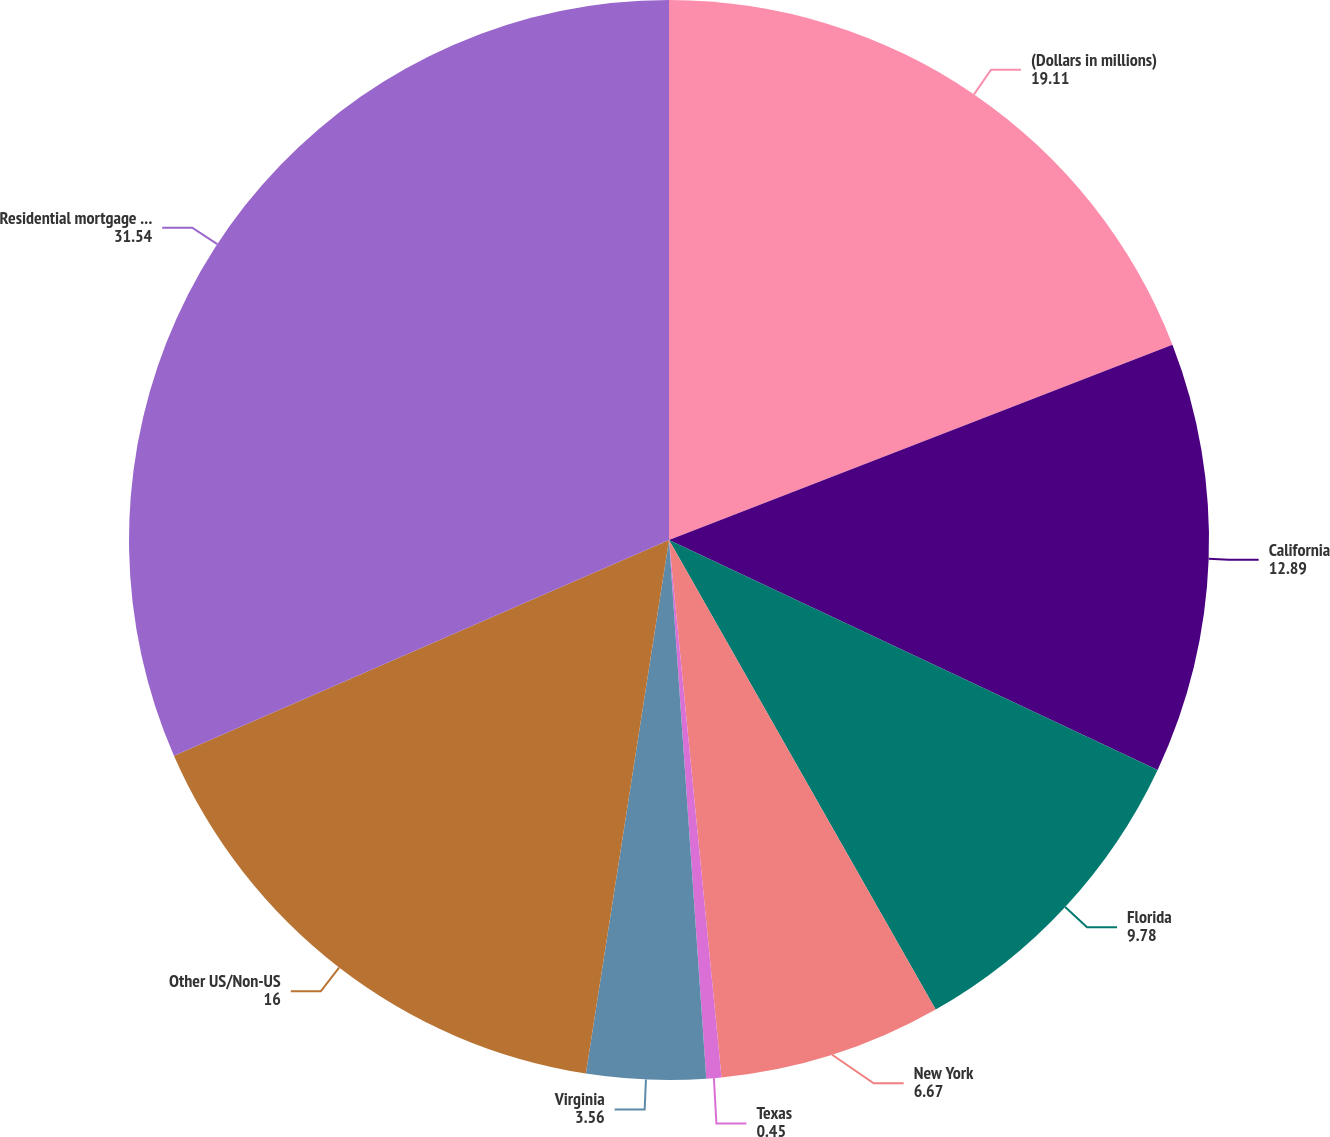Convert chart to OTSL. <chart><loc_0><loc_0><loc_500><loc_500><pie_chart><fcel>(Dollars in millions)<fcel>California<fcel>Florida<fcel>New York<fcel>Texas<fcel>Virginia<fcel>Other US/Non-US<fcel>Residential mortgage loans (2)<nl><fcel>19.11%<fcel>12.89%<fcel>9.78%<fcel>6.67%<fcel>0.45%<fcel>3.56%<fcel>16.0%<fcel>31.54%<nl></chart> 